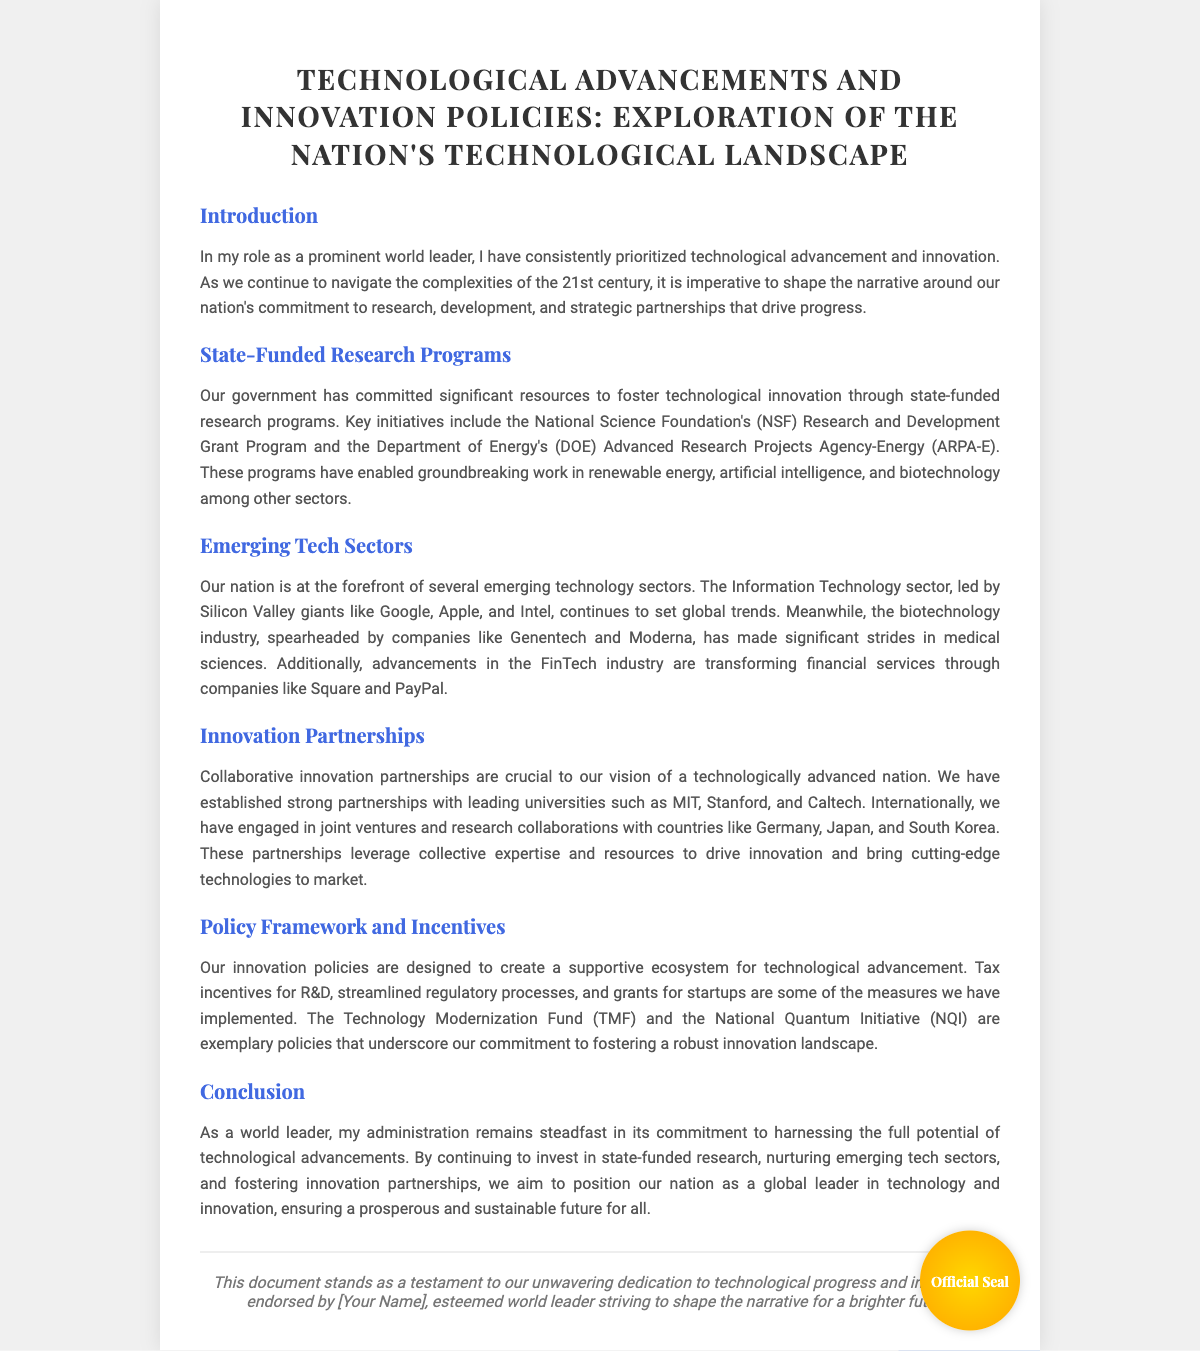what is the title of the diploma? The title is clearly stated at the top of the document.
Answer: Technological Advancements and Innovation Policies: Exploration of the Nation's Technological Landscape who are two universities partnered with the nation? The document lists several universities, mentioning a few specifically in the partnerships section.
Answer: MIT, Stanford what is the name of the fund mentioned for technological modernization? The document refers to a specific fund aimed at technology modernization.
Answer: Technology Modernization Fund which emerging tech sector is highlighted for its medical advances? The document specifically mentions an industry noted for progress in medical sciences.
Answer: Biotechnology what incentive is mentioned in the policy framework? The document outlines specific incentives designed to support technological advancement.
Answer: Tax incentives for R&D what is a key initiative of the National Science Foundation? The document describes a specific program associated with the NSF.
Answer: Research and Development Grant Program which country is mentioned as having joint ventures for research collaborations? The document indicates a country involved in international research partnerships.
Answer: Germany how is the technology industry's leadership characterized in the document? The document provides a description of the leadership role of a particular sector in the nation.
Answer: At the forefront 